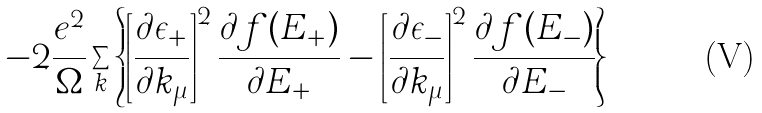Convert formula to latex. <formula><loc_0><loc_0><loc_500><loc_500>- 2 \frac { e ^ { 2 } } { \Omega } \sum _ { k } \left \{ \left [ \frac { \partial \epsilon _ { + } } { \partial k _ { \mu } } \right ] ^ { 2 } \frac { \partial f ( E _ { + } ) } { \partial E _ { + } } - \left [ \frac { \partial \epsilon _ { - } } { \partial k _ { \mu } } \right ] ^ { 2 } \frac { \partial f ( E _ { - } ) } { \partial E _ { - } } \right \}</formula> 